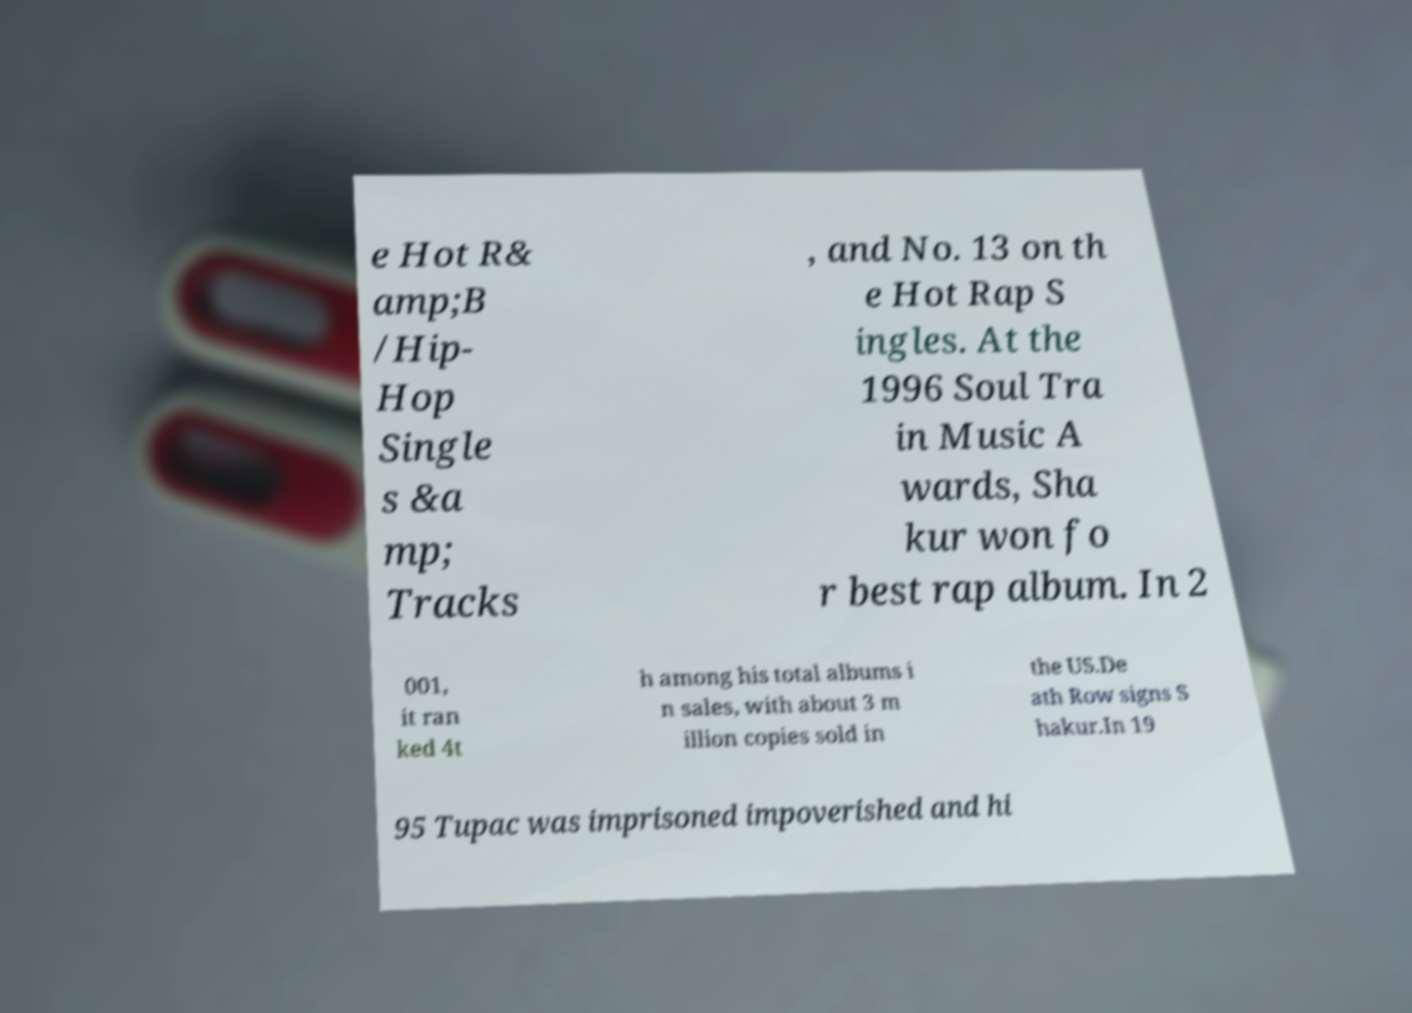Can you read and provide the text displayed in the image?This photo seems to have some interesting text. Can you extract and type it out for me? e Hot R& amp;B /Hip- Hop Single s &a mp; Tracks , and No. 13 on th e Hot Rap S ingles. At the 1996 Soul Tra in Music A wards, Sha kur won fo r best rap album. In 2 001, it ran ked 4t h among his total albums i n sales, with about 3 m illion copies sold in the US.De ath Row signs S hakur.In 19 95 Tupac was imprisoned impoverished and hi 